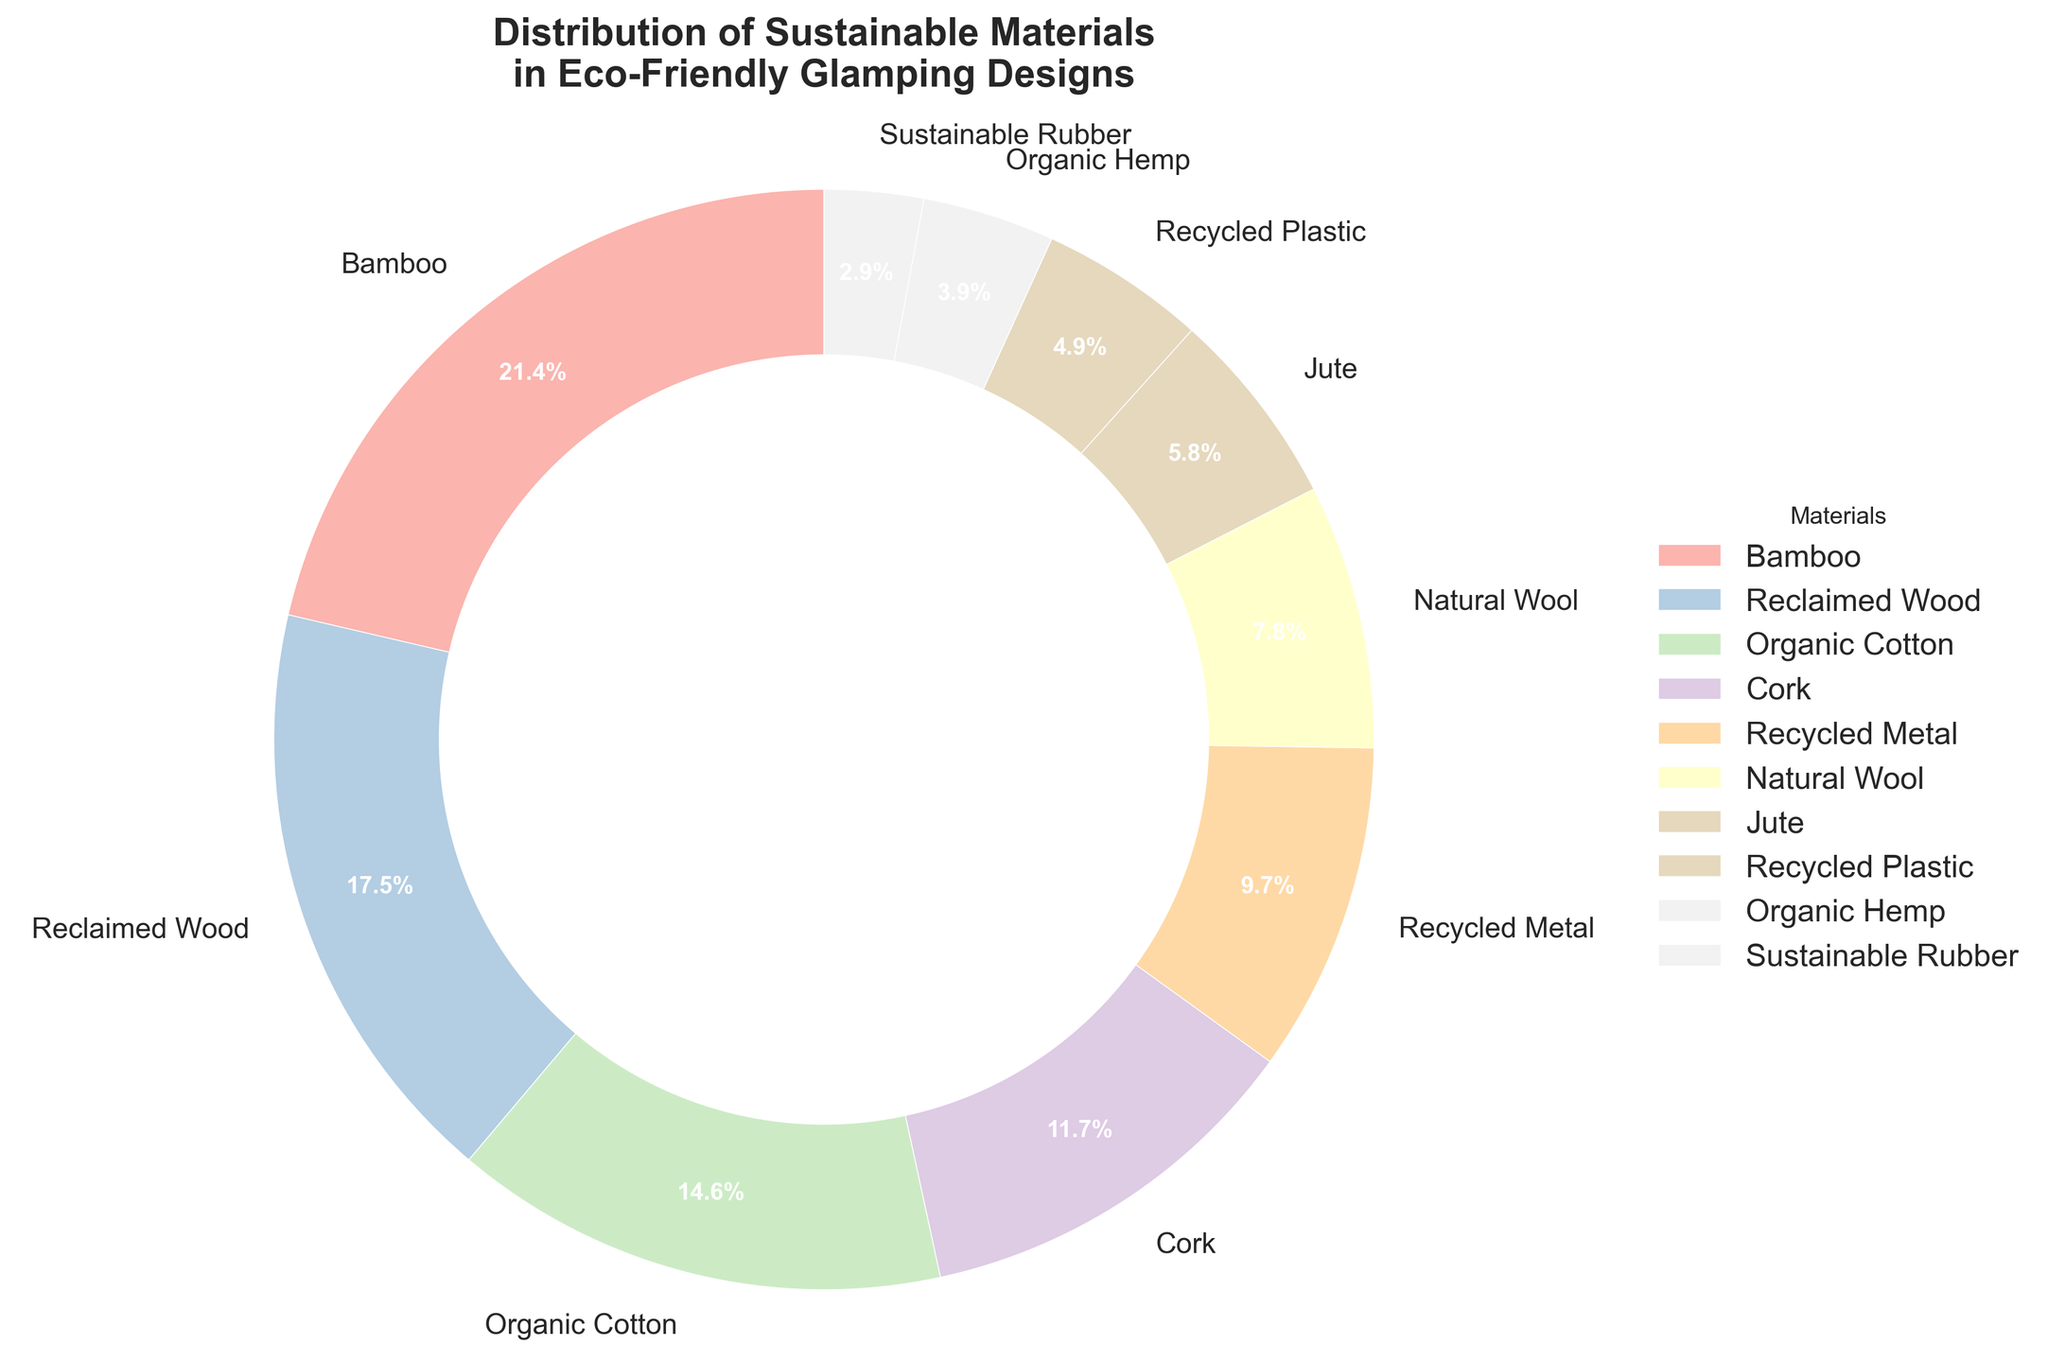Which material has the highest percentage in the pie chart? By looking at the pie chart, the largest slice corresponds to Bamboo, which has a percentage of 22%.
Answer: Bamboo Which two materials together account for approximately one-third of the total? Bamboo is 22% and Reclaimed Wood is 18%, so together they are 22% + 18% = 40%, which is more than one-third of the total 100%.
Answer: Bamboo and Reclaimed Wood What is the difference in percentage between Organic Cotton and Recycled Metal? The slice for Organic Cotton is 15% and for Recycled Metal is 10%, so the difference is 15% - 10% = 5%.
Answer: 5% Which material has a higher percentage, Jute or Organic Hemp? By observing the pie chart, Jute has a percentage of 6% while Organic Hemp has 4%. Therefore, Jute has a higher percentage than Organic Hemp.
Answer: Jute If you combine the percentages of the two smallest materials, will their total percentage be more than that of Cork? Sustainable Rubber is 3% and Organic Hemp is 4%, so their combined percentage is 3% +4% = 7%, which is less than Cork's 12%.
Answer: No How many materials have a percentage of 10% or higher? By examining the slices, Bamboo (22%), Reclaimed Wood (18%), Organic Cotton (15%), Cork (12%), and Recycled Metal (10%) all have percentages of 10% or higher. In total, that is 5 materials.
Answer: 5 What is the total percentage of materials that are plant-based? (Bamboo, Organic Cotton, Jute, Organic Hemp) Bamboo is 22%, Organic Cotton is 15%, Jute is 6% and Organic Hemp is 4%. Summing these up gives 22% + 15% + 6% + 4% = 47%.
Answer: 47% What is the average percentage of all materials? Summing all the percentages: 22% + 18% + 15% + 12% + 10% + 8% + 6% + 5% + 4% + 3% = 103%. Since there are 10 categories, the average is 103% / 10 = 10.3%.
Answer: 10.3% Which occupies a larger share, Natural Wool or Recycled Plastic? By looking at the pie chart, Natural Wool is 8% while Recycled Plastic is 5%. Therefore, Natural Wool occupies a larger share.
Answer: Natural Wool 